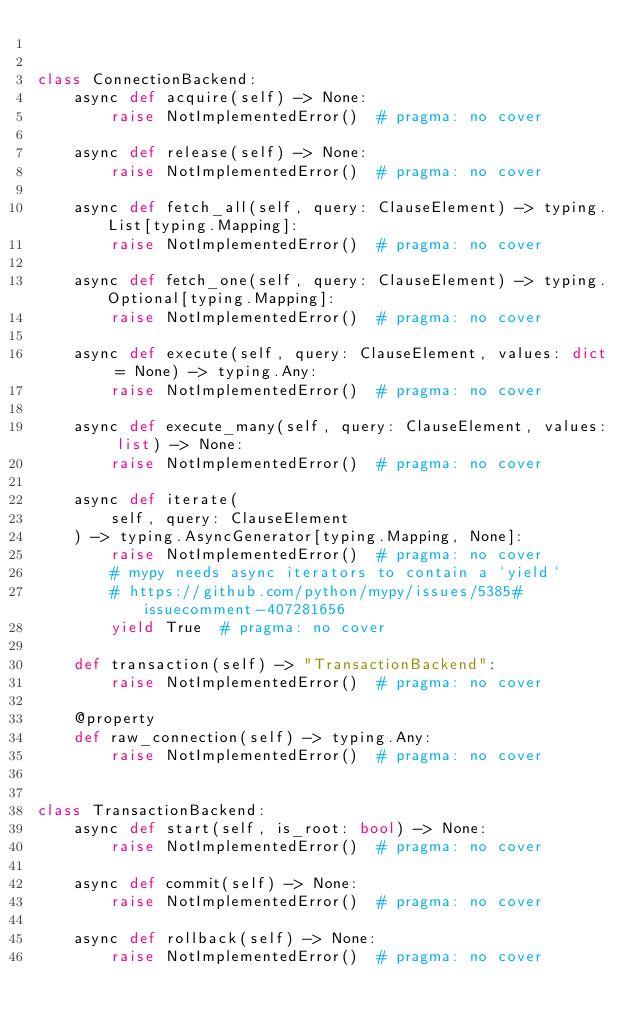Convert code to text. <code><loc_0><loc_0><loc_500><loc_500><_Python_>

class ConnectionBackend:
    async def acquire(self) -> None:
        raise NotImplementedError()  # pragma: no cover

    async def release(self) -> None:
        raise NotImplementedError()  # pragma: no cover

    async def fetch_all(self, query: ClauseElement) -> typing.List[typing.Mapping]:
        raise NotImplementedError()  # pragma: no cover

    async def fetch_one(self, query: ClauseElement) -> typing.Optional[typing.Mapping]:
        raise NotImplementedError()  # pragma: no cover

    async def execute(self, query: ClauseElement, values: dict = None) -> typing.Any:
        raise NotImplementedError()  # pragma: no cover

    async def execute_many(self, query: ClauseElement, values: list) -> None:
        raise NotImplementedError()  # pragma: no cover

    async def iterate(
        self, query: ClauseElement
    ) -> typing.AsyncGenerator[typing.Mapping, None]:
        raise NotImplementedError()  # pragma: no cover
        # mypy needs async iterators to contain a `yield`
        # https://github.com/python/mypy/issues/5385#issuecomment-407281656
        yield True  # pragma: no cover

    def transaction(self) -> "TransactionBackend":
        raise NotImplementedError()  # pragma: no cover

    @property
    def raw_connection(self) -> typing.Any:
        raise NotImplementedError()  # pragma: no cover


class TransactionBackend:
    async def start(self, is_root: bool) -> None:
        raise NotImplementedError()  # pragma: no cover

    async def commit(self) -> None:
        raise NotImplementedError()  # pragma: no cover

    async def rollback(self) -> None:
        raise NotImplementedError()  # pragma: no cover
</code> 